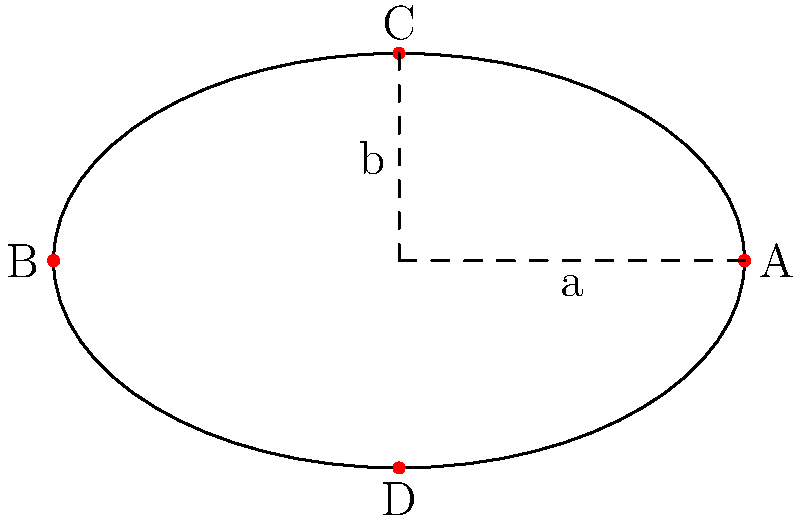Consider an elliptical racetrack with semi-major axis $a$ and semi-minor axis $b$. If the track's circumference is 2000 meters, and the ratio of $a$ to $b$ is 5:3, determine the optimal curvature at point A. How does this curvature compare to that at point C? Let's approach this step-by-step:

1) The circumference of an ellipse is approximated by Ramanujan's formula:
   $$C \approx \pi(a+b)\left(1 + \frac{3h}{10 + \sqrt{4-3h}}\right)$$
   where $h = \frac{(a-b)^2}{(a+b)^2}$

2) We're given that $C = 2000$ meters and $\frac{a}{b} = \frac{5}{3}$

3) Let $b = 3x$ and $a = 5x$. Substituting into the circumference formula:
   $$2000 \approx \pi(5x+3x)\left(1 + \frac{3h}{10 + \sqrt{4-3h}}\right)$$

4) Solving this equation numerically gives $x \approx 95.4$
   So, $a \approx 477$ m and $b \approx 286$ m

5) The curvature $\kappa$ at any point $(x,y)$ on an ellipse is given by:
   $$\kappa = \frac{ab}{(a^2\sin^2t + b^2\cos^2t)^{3/2}}$$
   where $t$ is the parameter in the parametric equation of the ellipse

6) At point A $(a,0)$, $\cos t = 1$ and $\sin t = 0$:
   $$\kappa_A = \frac{ab}{(b^2)^{3/2}} = \frac{a}{b^2} \approx 0.00583 \text{ m}^{-1}$$

7) At point C $(0,b)$, $\cos t = 0$ and $\sin t = 1$:
   $$\kappa_C = \frac{ab}{(a^2)^{3/2}} = \frac{b}{a^2} \approx 0.00126 \text{ m}^{-1}$$

8) The ratio of curvatures:
   $$\frac{\kappa_A}{\kappa_C} = \frac{a^3}{b^3} = \left(\frac{5}{3}\right)^3 \approx 4.63$$

Therefore, the curvature at point A is about 4.63 times greater than at point C.
Answer: $\kappa_A \approx 0.00583 \text{ m}^{-1}$; 4.63 times greater than at C 